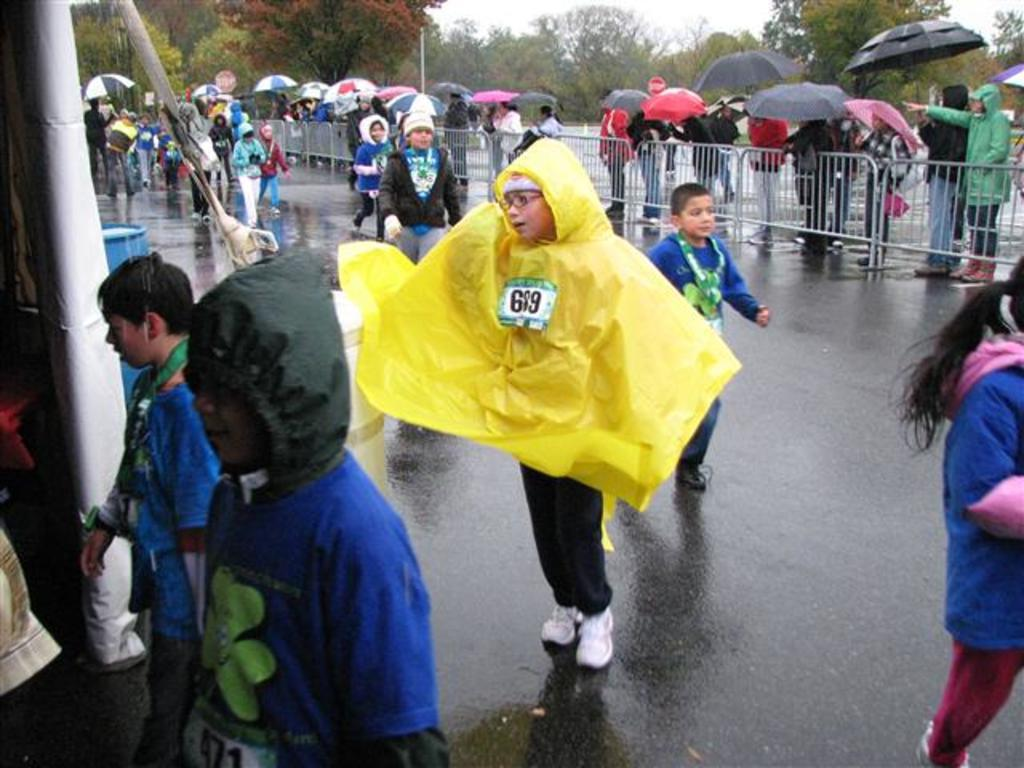What is located at the bottom of the image? There is a road at the bottom of the image. What are the children in the image doing? The children in the image are holding umbrellas. What can be seen in the background of the image? There are groups of trees in the background of the image. Where is the aunt in the image? There is no aunt present in the image. What type of destruction can be seen in the image? There is no destruction present in the image. 